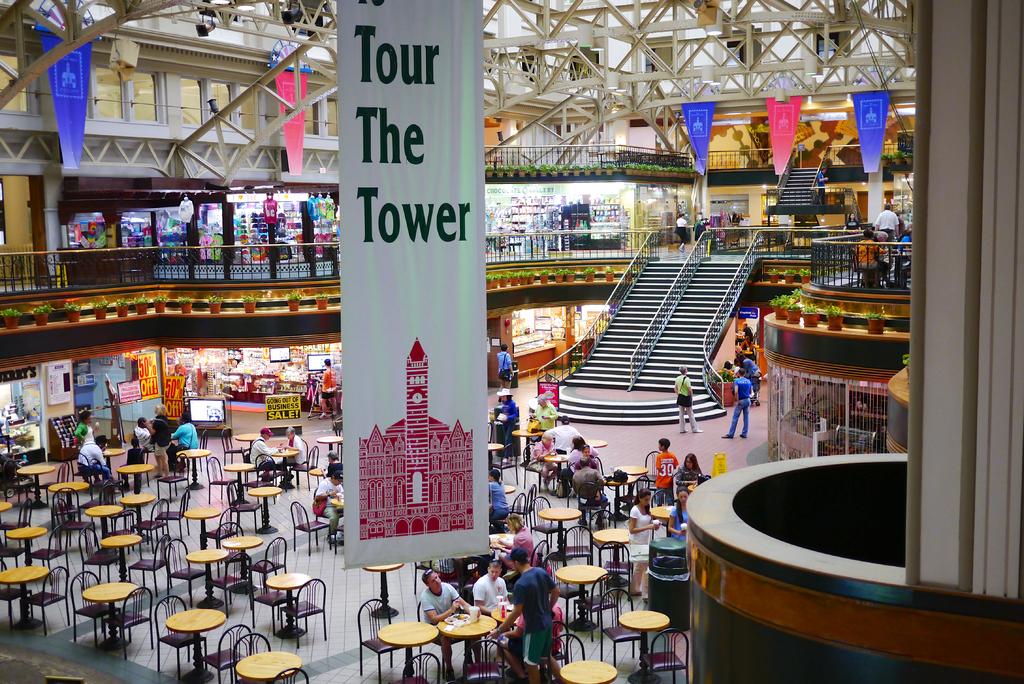What can you tour?
Your response must be concise. The tower. 